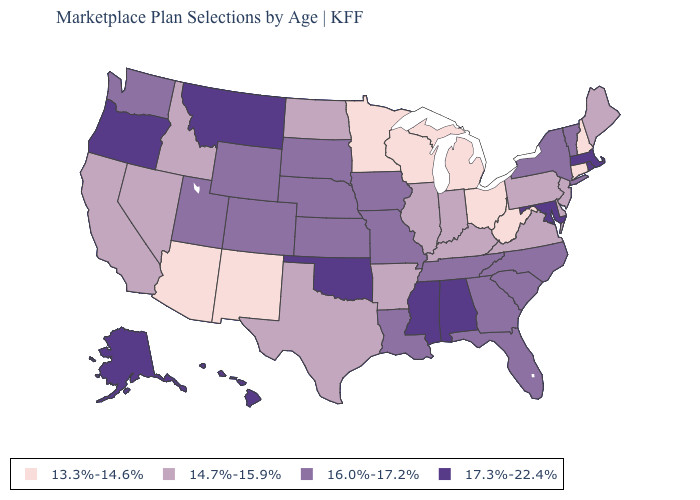What is the highest value in states that border Mississippi?
Short answer required. 17.3%-22.4%. Name the states that have a value in the range 14.7%-15.9%?
Quick response, please. Arkansas, California, Delaware, Idaho, Illinois, Indiana, Kentucky, Maine, Nevada, New Jersey, North Dakota, Pennsylvania, Texas, Virginia. What is the lowest value in the USA?
Keep it brief. 13.3%-14.6%. What is the value of Louisiana?
Concise answer only. 16.0%-17.2%. Among the states that border Utah , does Idaho have the highest value?
Quick response, please. No. Does the map have missing data?
Quick response, please. No. Name the states that have a value in the range 17.3%-22.4%?
Be succinct. Alabama, Alaska, Hawaii, Maryland, Massachusetts, Mississippi, Montana, Oklahoma, Oregon, Rhode Island. Does Nevada have the lowest value in the USA?
Concise answer only. No. Name the states that have a value in the range 17.3%-22.4%?
Answer briefly. Alabama, Alaska, Hawaii, Maryland, Massachusetts, Mississippi, Montana, Oklahoma, Oregon, Rhode Island. What is the value of Alaska?
Write a very short answer. 17.3%-22.4%. Which states hav the highest value in the Northeast?
Concise answer only. Massachusetts, Rhode Island. Among the states that border Iowa , does Minnesota have the highest value?
Concise answer only. No. What is the lowest value in the Northeast?
Be succinct. 13.3%-14.6%. Which states have the lowest value in the South?
Be succinct. West Virginia. What is the highest value in states that border Nevada?
Keep it brief. 17.3%-22.4%. 